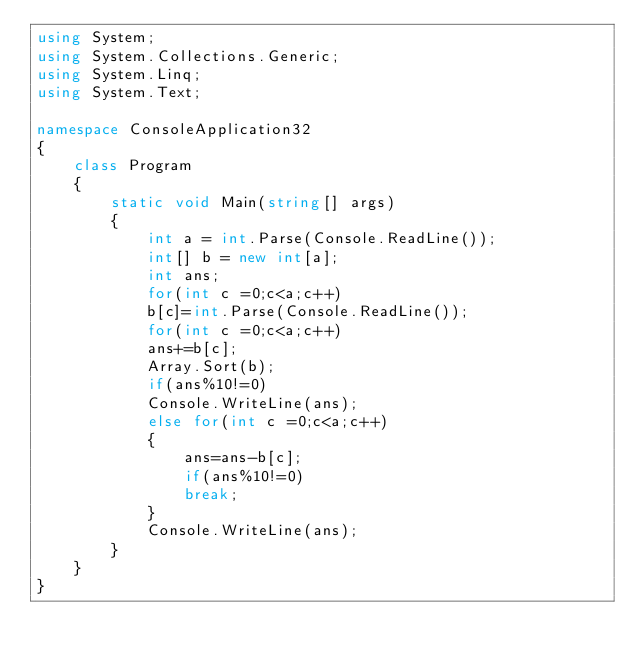Convert code to text. <code><loc_0><loc_0><loc_500><loc_500><_C#_>using System;
using System.Collections.Generic;
using System.Linq;
using System.Text;
 
namespace ConsoleApplication32
{
    class Program
    {
        static void Main(string[] args)
        {
			int a = int.Parse(Console.ReadLine());
			int[] b = new int[a];
			int ans;
			for(int c =0;c<a;c++)
			b[c]=int.Parse(Console.ReadLine());
			for(int c =0;c<a;c++)
			ans+=b[c];
			Array.Sort(b);
			if(ans%10!=0)
			Console.WriteLine(ans);
			else for(int c =0;c<a;c++)
			{
				ans=ans-b[c];
				if(ans%10!=0)
				break;
			}
			Console.WriteLine(ans);
		}
	}
}
</code> 